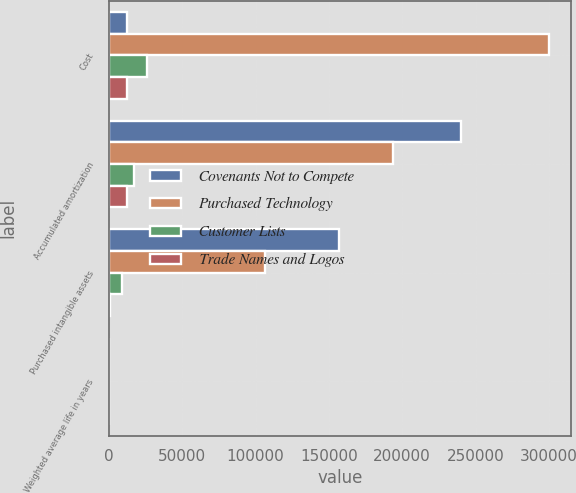Convert chart. <chart><loc_0><loc_0><loc_500><loc_500><stacked_bar_chart><ecel><fcel>Cost<fcel>Accumulated amortization<fcel>Purchased intangible assets<fcel>Weighted average life in years<nl><fcel>Covenants Not to Compete<fcel>12596<fcel>240386<fcel>156970<fcel>5<nl><fcel>Purchased Technology<fcel>299963<fcel>193563<fcel>106400<fcel>4<nl><fcel>Customer Lists<fcel>26248<fcel>17007<fcel>9241<fcel>5<nl><fcel>Trade Names and Logos<fcel>12596<fcel>12120<fcel>476<fcel>3<nl></chart> 